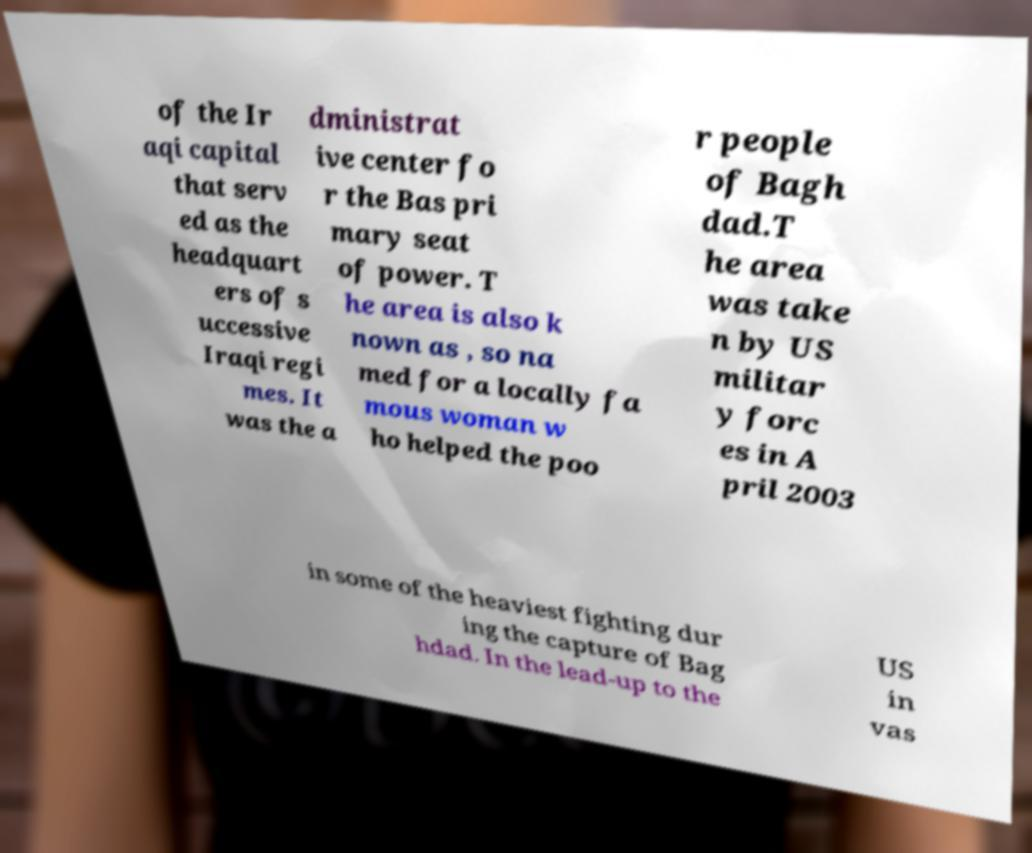For documentation purposes, I need the text within this image transcribed. Could you provide that? of the Ir aqi capital that serv ed as the headquart ers of s uccessive Iraqi regi mes. It was the a dministrat ive center fo r the Bas pri mary seat of power. T he area is also k nown as , so na med for a locally fa mous woman w ho helped the poo r people of Bagh dad.T he area was take n by US militar y forc es in A pril 2003 in some of the heaviest fighting dur ing the capture of Bag hdad. In the lead-up to the US in vas 